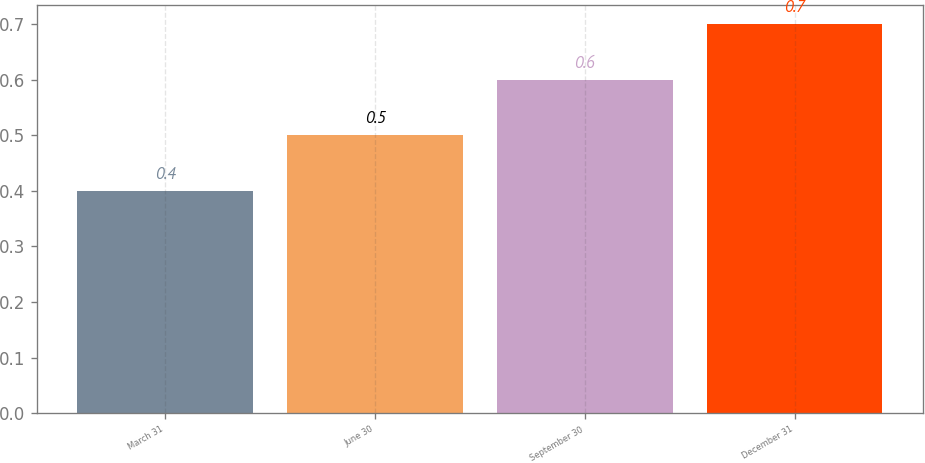<chart> <loc_0><loc_0><loc_500><loc_500><bar_chart><fcel>March 31<fcel>June 30<fcel>September 30<fcel>December 31<nl><fcel>0.4<fcel>0.5<fcel>0.6<fcel>0.7<nl></chart> 